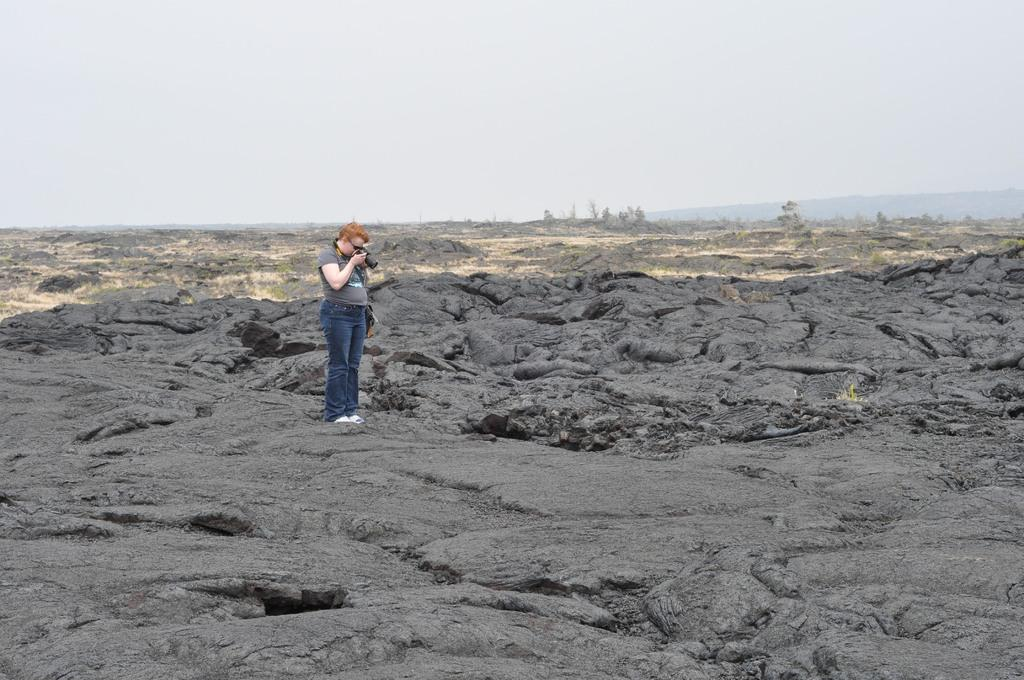What is the main subject of the image? There is a person standing in the center of the image. What is the person holding in the image? The person is holding a camera. What can be seen in the background of the image? The sky, plants, and grass are visible in the background of the image. What type of jeans is the police officer wearing in the image? There is no police officer or jeans present in the image. What disease can be seen affecting the plants in the image? There is no disease affecting the plants in the image; the plants appear healthy. 